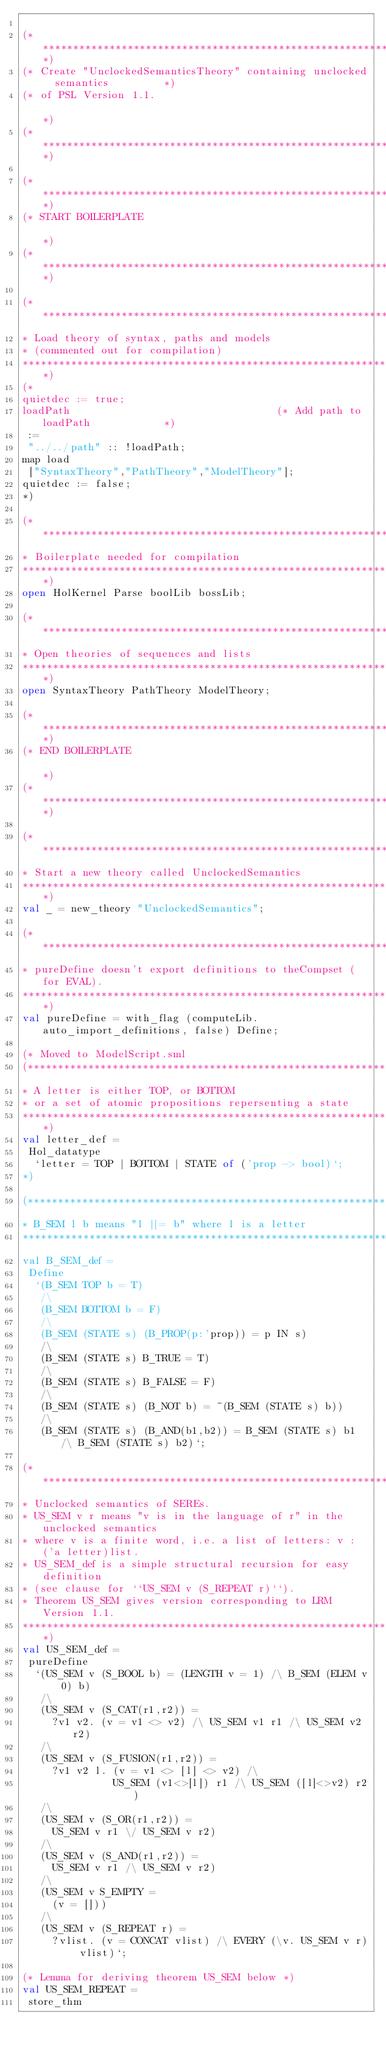Convert code to text. <code><loc_0><loc_0><loc_500><loc_500><_SML_>
(*****************************************************************************)
(* Create "UnclockedSemanticsTheory" containing unclocked  semantics         *)
(* of PSL Version 1.1.                                                       *)
(*****************************************************************************)

(*****************************************************************************)
(* START BOILERPLATE                                                         *)
(*****************************************************************************)

(******************************************************************************
* Load theory of syntax, paths and models
* (commented out for compilation)
******************************************************************************)
(*
quietdec := true;
loadPath                                  (* Add path to loadPath            *)
 :=
 "../../path" :: !loadPath;
map load
 ["SyntaxTheory","PathTheory","ModelTheory"];
quietdec := false;
*)

(******************************************************************************
* Boilerplate needed for compilation
******************************************************************************)
open HolKernel Parse boolLib bossLib;

(******************************************************************************
* Open theories of sequences and lists
******************************************************************************)
open SyntaxTheory PathTheory ModelTheory;

(*****************************************************************************)
(* END BOILERPLATE                                                           *)
(*****************************************************************************)

(******************************************************************************
* Start a new theory called UnclockedSemantics
******************************************************************************)
val _ = new_theory "UnclockedSemantics";

(******************************************************************************
* pureDefine doesn't export definitions to theCompset (for EVAL).
******************************************************************************)
val pureDefine = with_flag (computeLib.auto_import_definitions, false) Define;

(* Moved to ModelScript.sml
(******************************************************************************
* A letter is either TOP, or BOTTOM
* or a set of atomic propositions repersenting a state
******************************************************************************)
val letter_def =
 Hol_datatype
  `letter = TOP | BOTTOM | STATE of ('prop -> bool)`;
*)

(******************************************************************************
* B_SEM l b means "l ||= b" where l is a letter
******************************************************************************)
val B_SEM_def =
 Define
  `(B_SEM TOP b = T)
   /\
   (B_SEM BOTTOM b = F)
   /\
   (B_SEM (STATE s) (B_PROP(p:'prop)) = p IN s)
   /\
   (B_SEM (STATE s) B_TRUE = T)
   /\
   (B_SEM (STATE s) B_FALSE = F)
   /\
   (B_SEM (STATE s) (B_NOT b) = ~(B_SEM (STATE s) b))
   /\
   (B_SEM (STATE s) (B_AND(b1,b2)) = B_SEM (STATE s) b1 /\ B_SEM (STATE s) b2)`;

(******************************************************************************
* Unclocked semantics of SEREs.
* US_SEM v r means "v is in the language of r" in the unclocked semantics
* where v is a finite word, i.e. a list of letters: v :  ('a letter)list.
* US_SEM_def is a simple structural recursion for easy definition
* (see clause for ``US_SEM v (S_REPEAT r)``).
* Theorem US_SEM gives version corresponding to LRM Version 1.1.
******************************************************************************)
val US_SEM_def =
 pureDefine
  `(US_SEM v (S_BOOL b) = (LENGTH v = 1) /\ B_SEM (ELEM v 0) b)
   /\
   (US_SEM v (S_CAT(r1,r2)) =
     ?v1 v2. (v = v1 <> v2) /\ US_SEM v1 r1 /\ US_SEM v2 r2)
   /\
   (US_SEM v (S_FUSION(r1,r2)) =
     ?v1 v2 l. (v = v1 <> [l] <> v2) /\
               US_SEM (v1<>[l]) r1 /\ US_SEM ([l]<>v2) r2)
   /\
   (US_SEM v (S_OR(r1,r2)) =
     US_SEM v r1 \/ US_SEM v r2)
   /\
   (US_SEM v (S_AND(r1,r2)) =
     US_SEM v r1 /\ US_SEM v r2)
   /\
   (US_SEM v S_EMPTY =
     (v = []))
   /\
   (US_SEM v (S_REPEAT r) =
     ?vlist. (v = CONCAT vlist) /\ EVERY (\v. US_SEM v r) vlist)`;

(* Lemma for deriving theorem US_SEM below *)
val US_SEM_REPEAT =
 store_thm</code> 